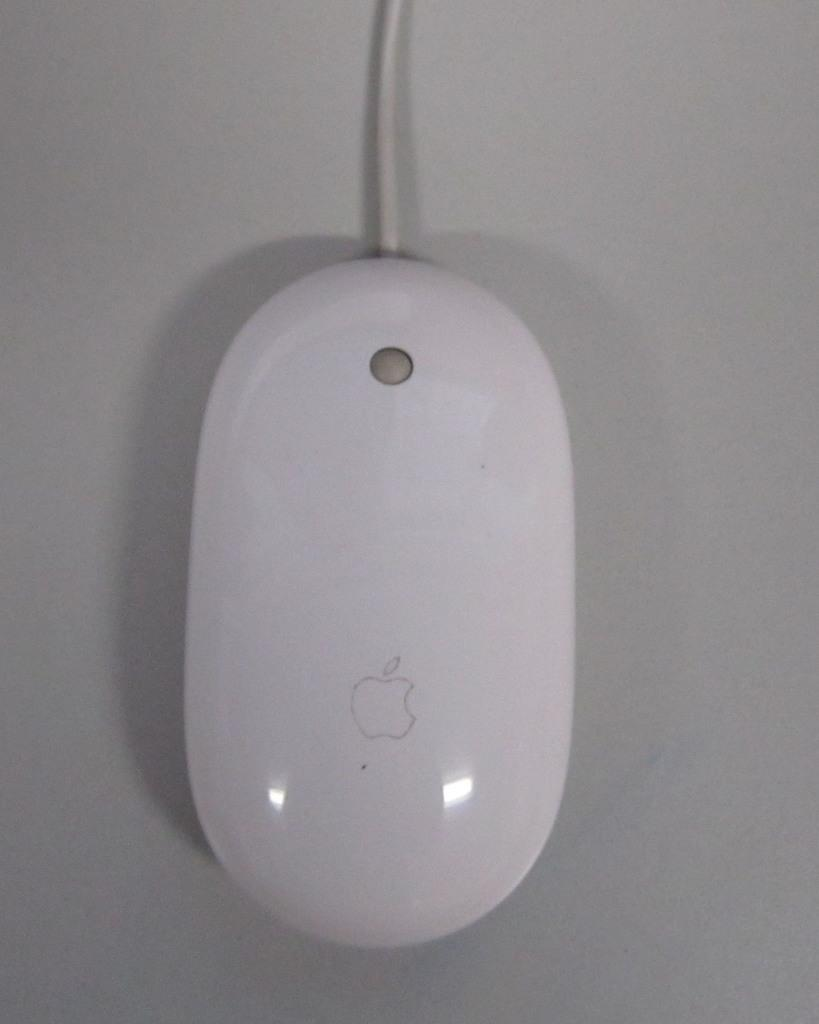What type of animal is in the image? There is a mouse in the image. Where is the mouse located? The mouse is on a table. What type of rabbit is managing the army in the image? There is no rabbit or army present in the image; it only features a mouse on a table. 